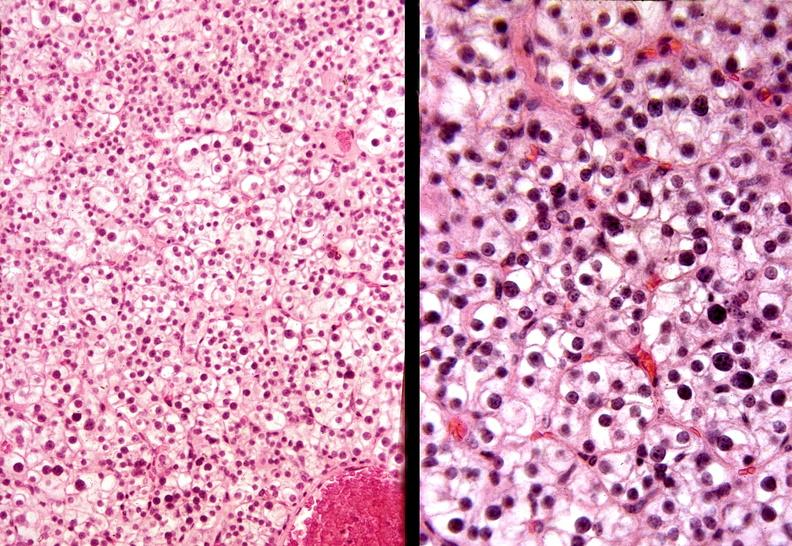does an opened peritoneal cavity cause by fibrous band strangulation show parathyroid, adenoma, functional?
Answer the question using a single word or phrase. No 